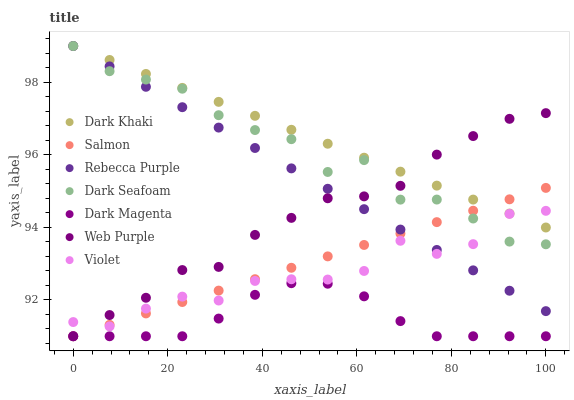Does Dark Magenta have the minimum area under the curve?
Answer yes or no. Yes. Does Dark Khaki have the maximum area under the curve?
Answer yes or no. Yes. Does Salmon have the minimum area under the curve?
Answer yes or no. No. Does Salmon have the maximum area under the curve?
Answer yes or no. No. Is Rebecca Purple the smoothest?
Answer yes or no. Yes. Is Dark Seafoam the roughest?
Answer yes or no. Yes. Is Salmon the smoothest?
Answer yes or no. No. Is Salmon the roughest?
Answer yes or no. No. Does Dark Magenta have the lowest value?
Answer yes or no. Yes. Does Dark Seafoam have the lowest value?
Answer yes or no. No. Does Rebecca Purple have the highest value?
Answer yes or no. Yes. Does Salmon have the highest value?
Answer yes or no. No. Is Dark Magenta less than Dark Khaki?
Answer yes or no. Yes. Is Dark Khaki greater than Dark Magenta?
Answer yes or no. Yes. Does Dark Khaki intersect Dark Seafoam?
Answer yes or no. Yes. Is Dark Khaki less than Dark Seafoam?
Answer yes or no. No. Is Dark Khaki greater than Dark Seafoam?
Answer yes or no. No. Does Dark Magenta intersect Dark Khaki?
Answer yes or no. No. 